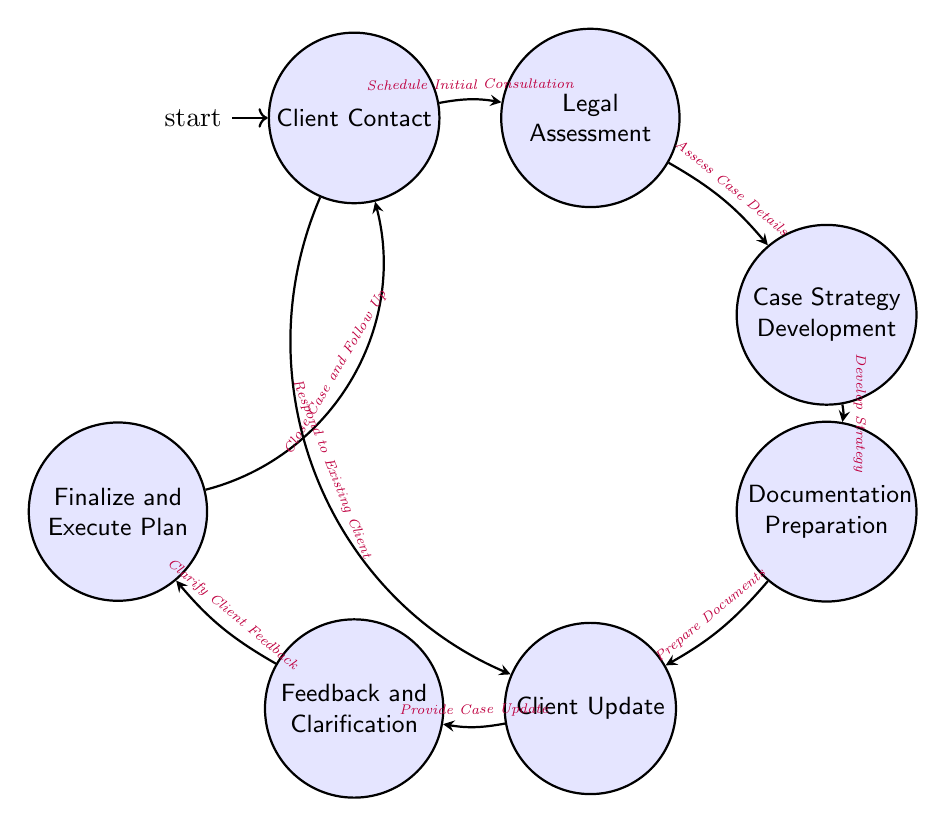What are the states in the diagram? The diagram contains several states: Client Contact, Legal Assessment, Case Strategy Development, Documentation Preparation, Client Update, Feedback and Clarification, and Finalize and Execute Plan.
Answer: Client Contact, Legal Assessment, Case Strategy Development, Documentation Preparation, Client Update, Feedback and Clarification, Finalize and Execute Plan How many transitions are there in the diagram? The diagram displays seven transitions connecting the various states together.
Answer: 7 What action connects Client Contact to Legal Assessment? The transition from Client Contact to Legal Assessment is labeled with the action "Schedule Initial Consultation."
Answer: Schedule Initial Consultation Which state follows Documentation Preparation? According to the diagram, the state that comes after Documentation Preparation is Client Update.
Answer: Client Update What action occurs after providing a case update? The action that follows providing a case update is "Clarify Client Feedback," which leads to the Feedback and Clarification state.
Answer: Clarify Client Feedback What state does the diagram return to after finalizing and executing the plan? After finalizing and executing the plan, the diagram indicates a return to the Client Contact state.
Answer: Client Contact Which two states are reachable from Client Contact? From the Client Contact state, you can either move to Legal Assessment by scheduling an initial consultation or respond to an existing client, leading to Client Update.
Answer: Legal Assessment, Client Update What is the first action taken in the diagram? The initial action in the diagram is to "Schedule Initial Consultation," which begins the process from the Client Contact state to the Legal Assessment state.
Answer: Schedule Initial Consultation 